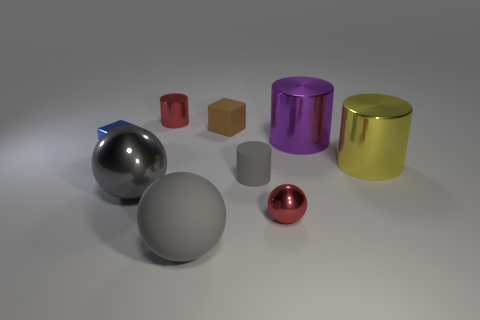Add 1 large yellow metallic cylinders. How many objects exist? 10 Subtract all spheres. How many objects are left? 6 Subtract all cyan metal cubes. Subtract all big balls. How many objects are left? 7 Add 1 gray metal balls. How many gray metal balls are left? 2 Add 4 big brown cubes. How many big brown cubes exist? 4 Subtract 0 blue cylinders. How many objects are left? 9 